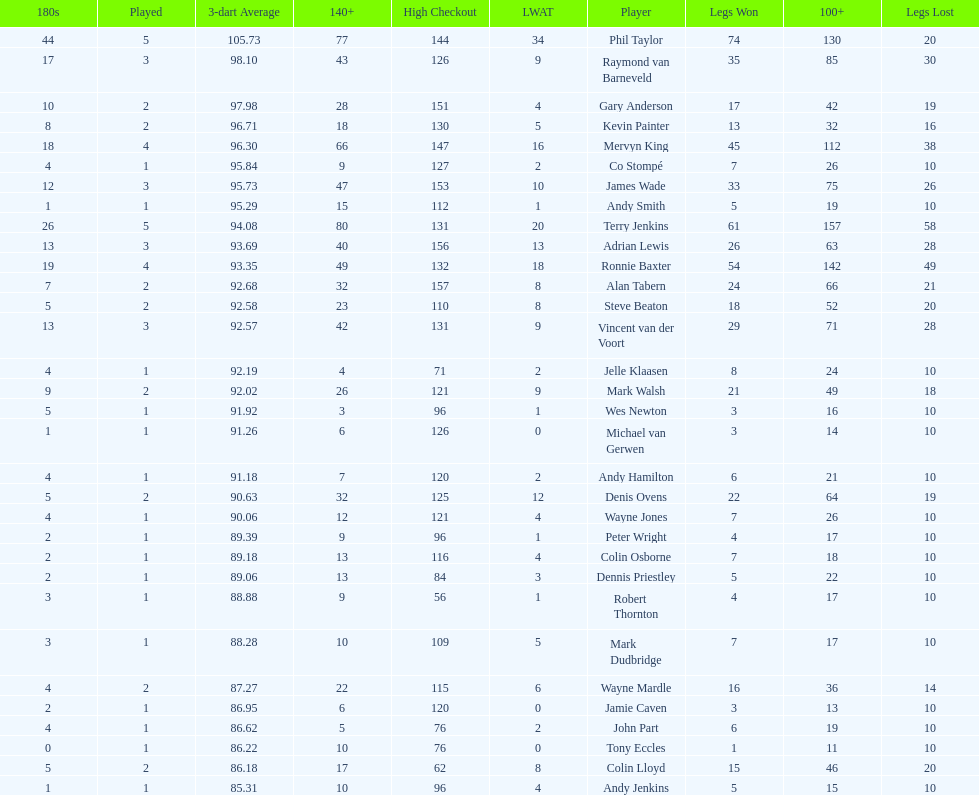How many players in the 2009 world matchplay won at least 30 legs? 6. 